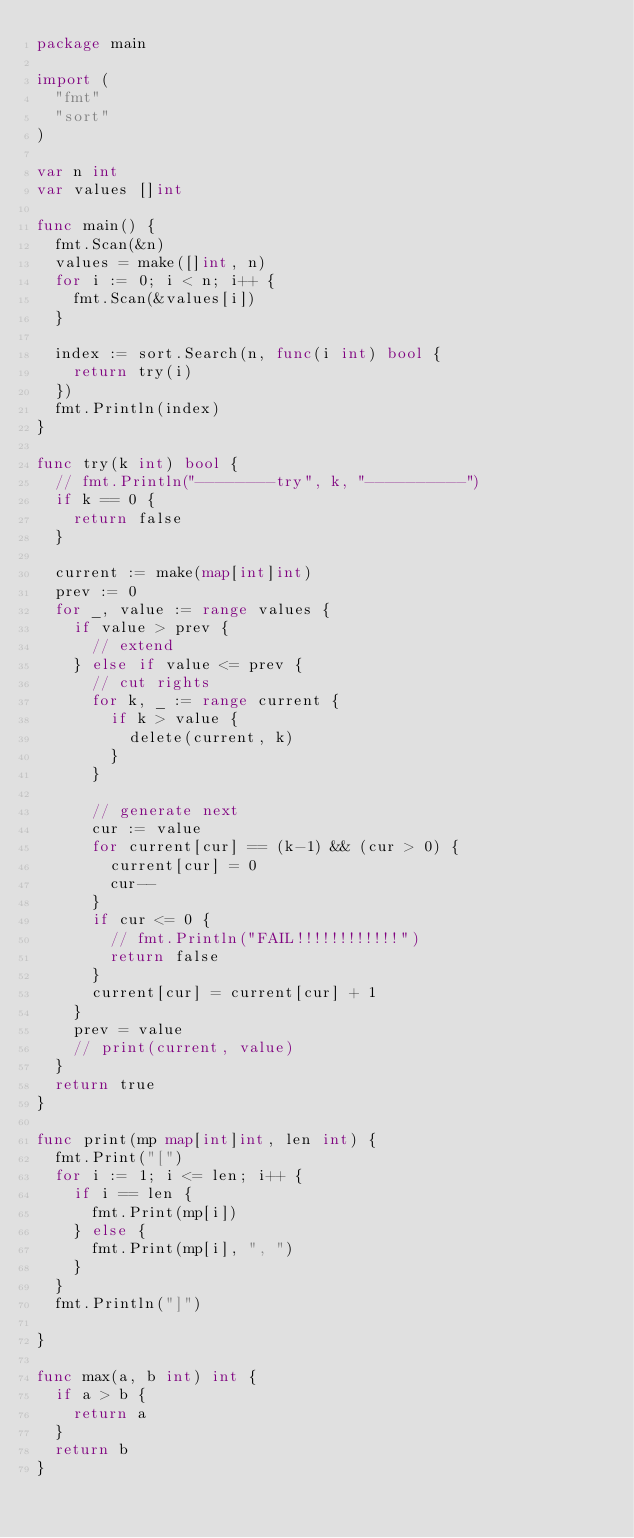Convert code to text. <code><loc_0><loc_0><loc_500><loc_500><_Go_>package main

import (
	"fmt"
	"sort"
)

var n int
var values []int

func main() {
	fmt.Scan(&n)
	values = make([]int, n)
	for i := 0; i < n; i++ {
		fmt.Scan(&values[i])
	}

	index := sort.Search(n, func(i int) bool {
		return try(i)
	})
	fmt.Println(index)
}

func try(k int) bool {
	// fmt.Println("--------try", k, "----------")
	if k == 0 {
		return false
	}

	current := make(map[int]int)
	prev := 0
	for _, value := range values {
		if value > prev {
			// extend
		} else if value <= prev {
			// cut rights
			for k, _ := range current {
				if k > value {
					delete(current, k)
				}
			}

			// generate next
			cur := value
			for current[cur] == (k-1) && (cur > 0) {
				current[cur] = 0
				cur--
			}
			if cur <= 0 {
				// fmt.Println("FAIL!!!!!!!!!!!!")
				return false
			}
			current[cur] = current[cur] + 1
		}
		prev = value
		// print(current, value)
	}
	return true
}

func print(mp map[int]int, len int) {
	fmt.Print("[")
	for i := 1; i <= len; i++ {
		if i == len {
			fmt.Print(mp[i])
		} else {
			fmt.Print(mp[i], ", ")
		}
	}
	fmt.Println("]")

}

func max(a, b int) int {
	if a > b {
		return a
	}
	return b
}
</code> 